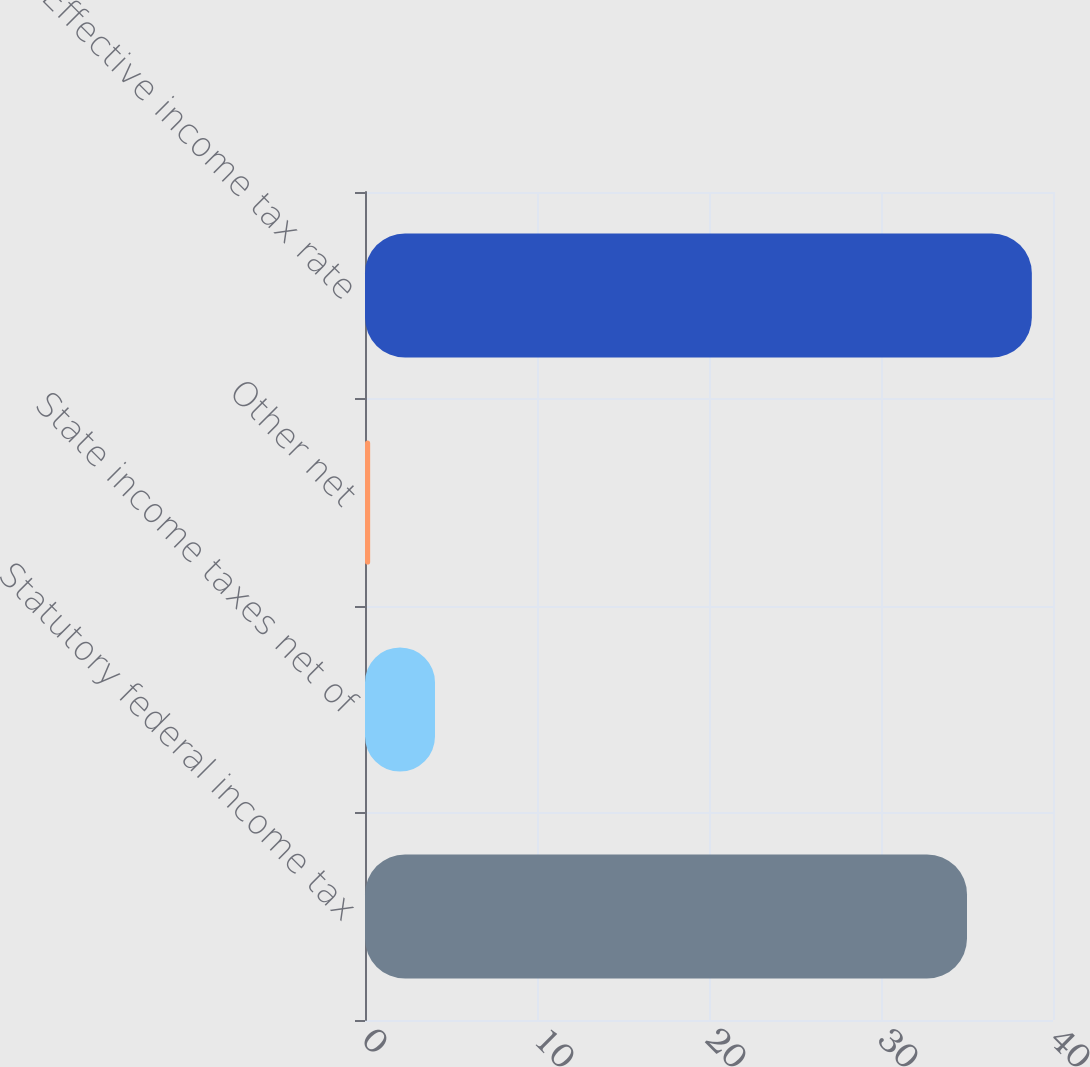Convert chart. <chart><loc_0><loc_0><loc_500><loc_500><bar_chart><fcel>Statutory federal income tax<fcel>State income taxes net of<fcel>Other net<fcel>Effective income tax rate<nl><fcel>35<fcel>4.07<fcel>0.3<fcel>38.77<nl></chart> 